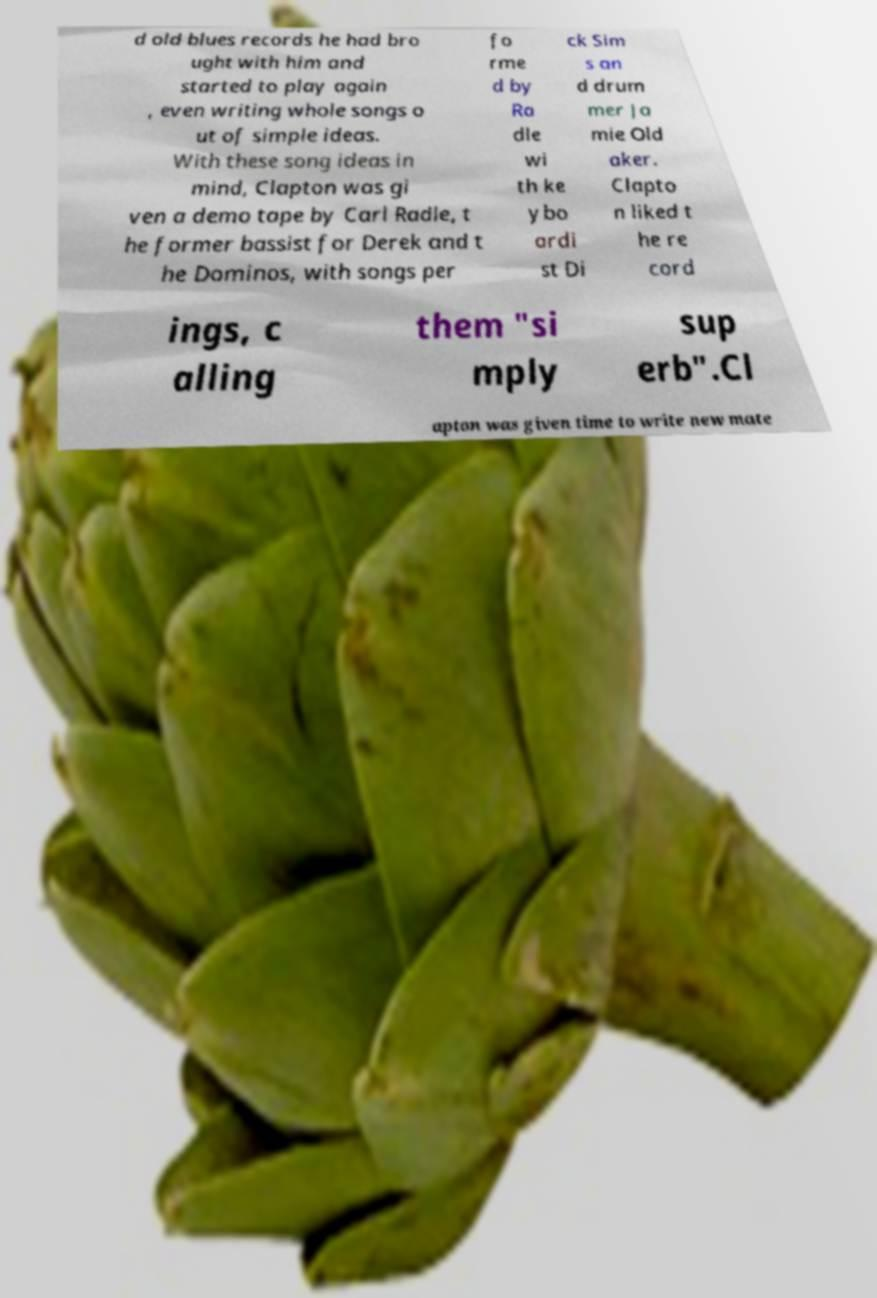What messages or text are displayed in this image? I need them in a readable, typed format. d old blues records he had bro ught with him and started to play again , even writing whole songs o ut of simple ideas. With these song ideas in mind, Clapton was gi ven a demo tape by Carl Radle, t he former bassist for Derek and t he Dominos, with songs per fo rme d by Ra dle wi th ke ybo ardi st Di ck Sim s an d drum mer Ja mie Old aker. Clapto n liked t he re cord ings, c alling them "si mply sup erb".Cl apton was given time to write new mate 